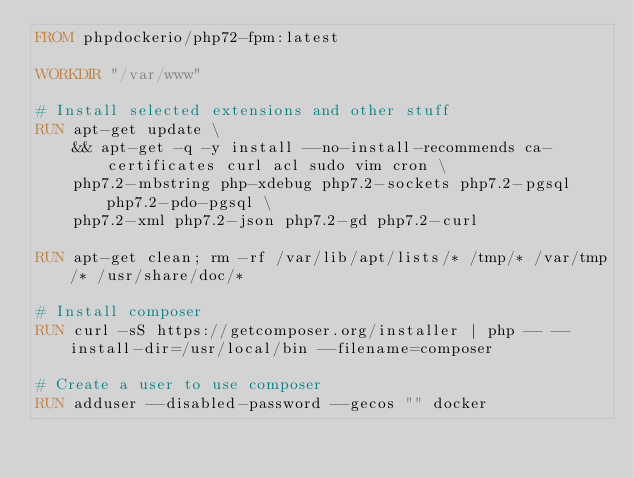Convert code to text. <code><loc_0><loc_0><loc_500><loc_500><_Dockerfile_>FROM phpdockerio/php72-fpm:latest

WORKDIR "/var/www"

# Install selected extensions and other stuff
RUN apt-get update \
    && apt-get -q -y install --no-install-recommends ca-certificates curl acl sudo vim cron \
    php7.2-mbstring php-xdebug php7.2-sockets php7.2-pgsql php7.2-pdo-pgsql \
    php7.2-xml php7.2-json php7.2-gd php7.2-curl

RUN apt-get clean; rm -rf /var/lib/apt/lists/* /tmp/* /var/tmp/* /usr/share/doc/*

# Install composer
RUN curl -sS https://getcomposer.org/installer | php -- --install-dir=/usr/local/bin --filename=composer

# Create a user to use composer
RUN adduser --disabled-password --gecos "" docker
</code> 